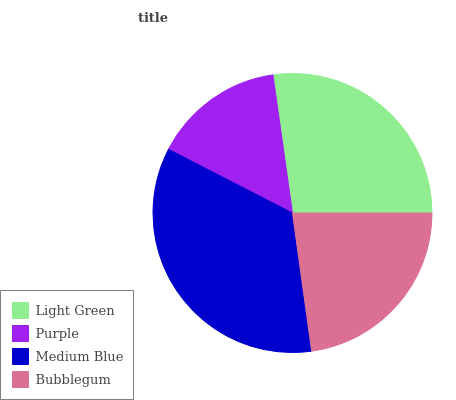Is Purple the minimum?
Answer yes or no. Yes. Is Medium Blue the maximum?
Answer yes or no. Yes. Is Medium Blue the minimum?
Answer yes or no. No. Is Purple the maximum?
Answer yes or no. No. Is Medium Blue greater than Purple?
Answer yes or no. Yes. Is Purple less than Medium Blue?
Answer yes or no. Yes. Is Purple greater than Medium Blue?
Answer yes or no. No. Is Medium Blue less than Purple?
Answer yes or no. No. Is Light Green the high median?
Answer yes or no. Yes. Is Bubblegum the low median?
Answer yes or no. Yes. Is Bubblegum the high median?
Answer yes or no. No. Is Medium Blue the low median?
Answer yes or no. No. 